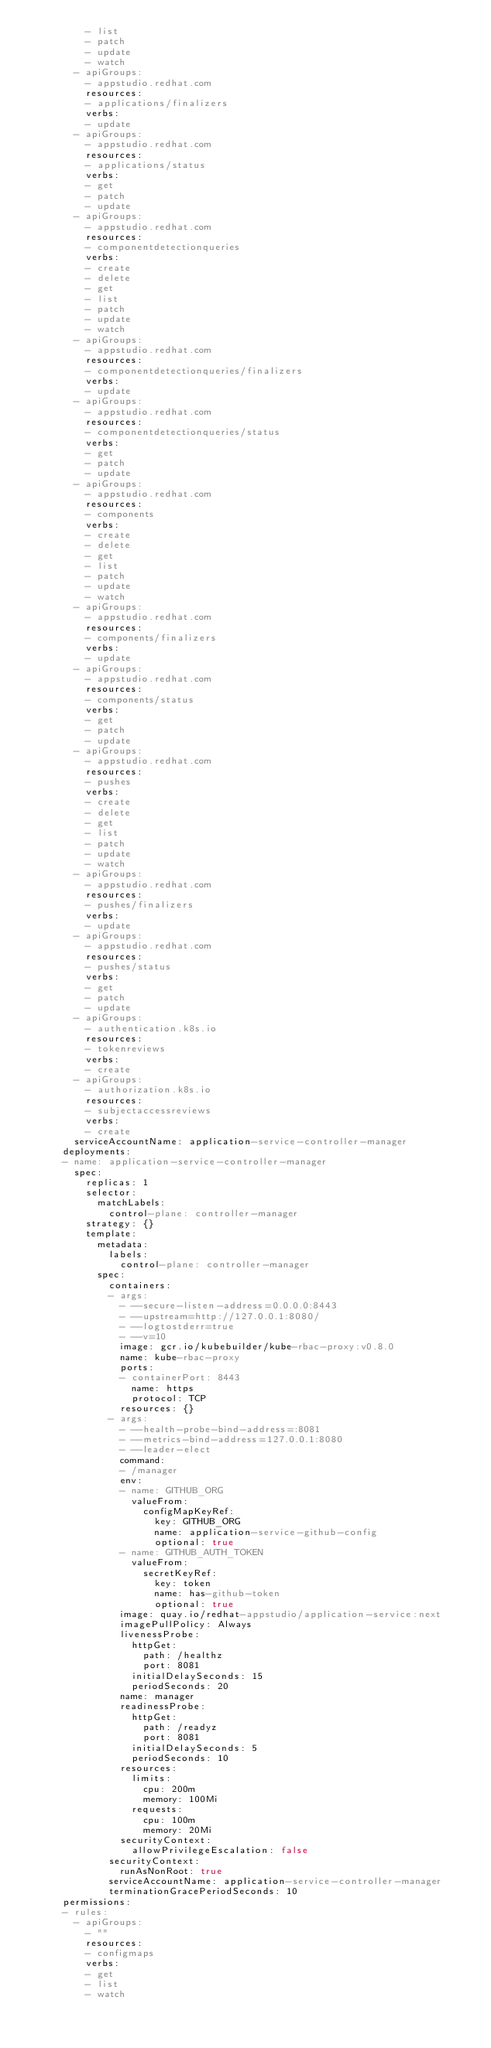Convert code to text. <code><loc_0><loc_0><loc_500><loc_500><_YAML_>          - list
          - patch
          - update
          - watch
        - apiGroups:
          - appstudio.redhat.com
          resources:
          - applications/finalizers
          verbs:
          - update
        - apiGroups:
          - appstudio.redhat.com
          resources:
          - applications/status
          verbs:
          - get
          - patch
          - update
        - apiGroups:
          - appstudio.redhat.com
          resources:
          - componentdetectionqueries
          verbs:
          - create
          - delete
          - get
          - list
          - patch
          - update
          - watch
        - apiGroups:
          - appstudio.redhat.com
          resources:
          - componentdetectionqueries/finalizers
          verbs:
          - update
        - apiGroups:
          - appstudio.redhat.com
          resources:
          - componentdetectionqueries/status
          verbs:
          - get
          - patch
          - update
        - apiGroups:
          - appstudio.redhat.com
          resources:
          - components
          verbs:
          - create
          - delete
          - get
          - list
          - patch
          - update
          - watch
        - apiGroups:
          - appstudio.redhat.com
          resources:
          - components/finalizers
          verbs:
          - update
        - apiGroups:
          - appstudio.redhat.com
          resources:
          - components/status
          verbs:
          - get
          - patch
          - update
        - apiGroups:
          - appstudio.redhat.com
          resources:
          - pushes
          verbs:
          - create
          - delete
          - get
          - list
          - patch
          - update
          - watch
        - apiGroups:
          - appstudio.redhat.com
          resources:
          - pushes/finalizers
          verbs:
          - update
        - apiGroups:
          - appstudio.redhat.com
          resources:
          - pushes/status
          verbs:
          - get
          - patch
          - update
        - apiGroups:
          - authentication.k8s.io
          resources:
          - tokenreviews
          verbs:
          - create
        - apiGroups:
          - authorization.k8s.io
          resources:
          - subjectaccessreviews
          verbs:
          - create
        serviceAccountName: application-service-controller-manager
      deployments:
      - name: application-service-controller-manager
        spec:
          replicas: 1
          selector:
            matchLabels:
              control-plane: controller-manager
          strategy: {}
          template:
            metadata:
              labels:
                control-plane: controller-manager
            spec:
              containers:
              - args:
                - --secure-listen-address=0.0.0.0:8443
                - --upstream=http://127.0.0.1:8080/
                - --logtostderr=true
                - --v=10
                image: gcr.io/kubebuilder/kube-rbac-proxy:v0.8.0
                name: kube-rbac-proxy
                ports:
                - containerPort: 8443
                  name: https
                  protocol: TCP
                resources: {}
              - args:
                - --health-probe-bind-address=:8081
                - --metrics-bind-address=127.0.0.1:8080
                - --leader-elect
                command:
                - /manager
                env:
                - name: GITHUB_ORG
                  valueFrom:
                    configMapKeyRef:
                      key: GITHUB_ORG
                      name: application-service-github-config
                      optional: true
                - name: GITHUB_AUTH_TOKEN
                  valueFrom:
                    secretKeyRef:
                      key: token
                      name: has-github-token
                      optional: true
                image: quay.io/redhat-appstudio/application-service:next
                imagePullPolicy: Always
                livenessProbe:
                  httpGet:
                    path: /healthz
                    port: 8081
                  initialDelaySeconds: 15
                  periodSeconds: 20
                name: manager
                readinessProbe:
                  httpGet:
                    path: /readyz
                    port: 8081
                  initialDelaySeconds: 5
                  periodSeconds: 10
                resources:
                  limits:
                    cpu: 200m
                    memory: 100Mi
                  requests:
                    cpu: 100m
                    memory: 20Mi
                securityContext:
                  allowPrivilegeEscalation: false
              securityContext:
                runAsNonRoot: true
              serviceAccountName: application-service-controller-manager
              terminationGracePeriodSeconds: 10
      permissions:
      - rules:
        - apiGroups:
          - ""
          resources:
          - configmaps
          verbs:
          - get
          - list
          - watch</code> 